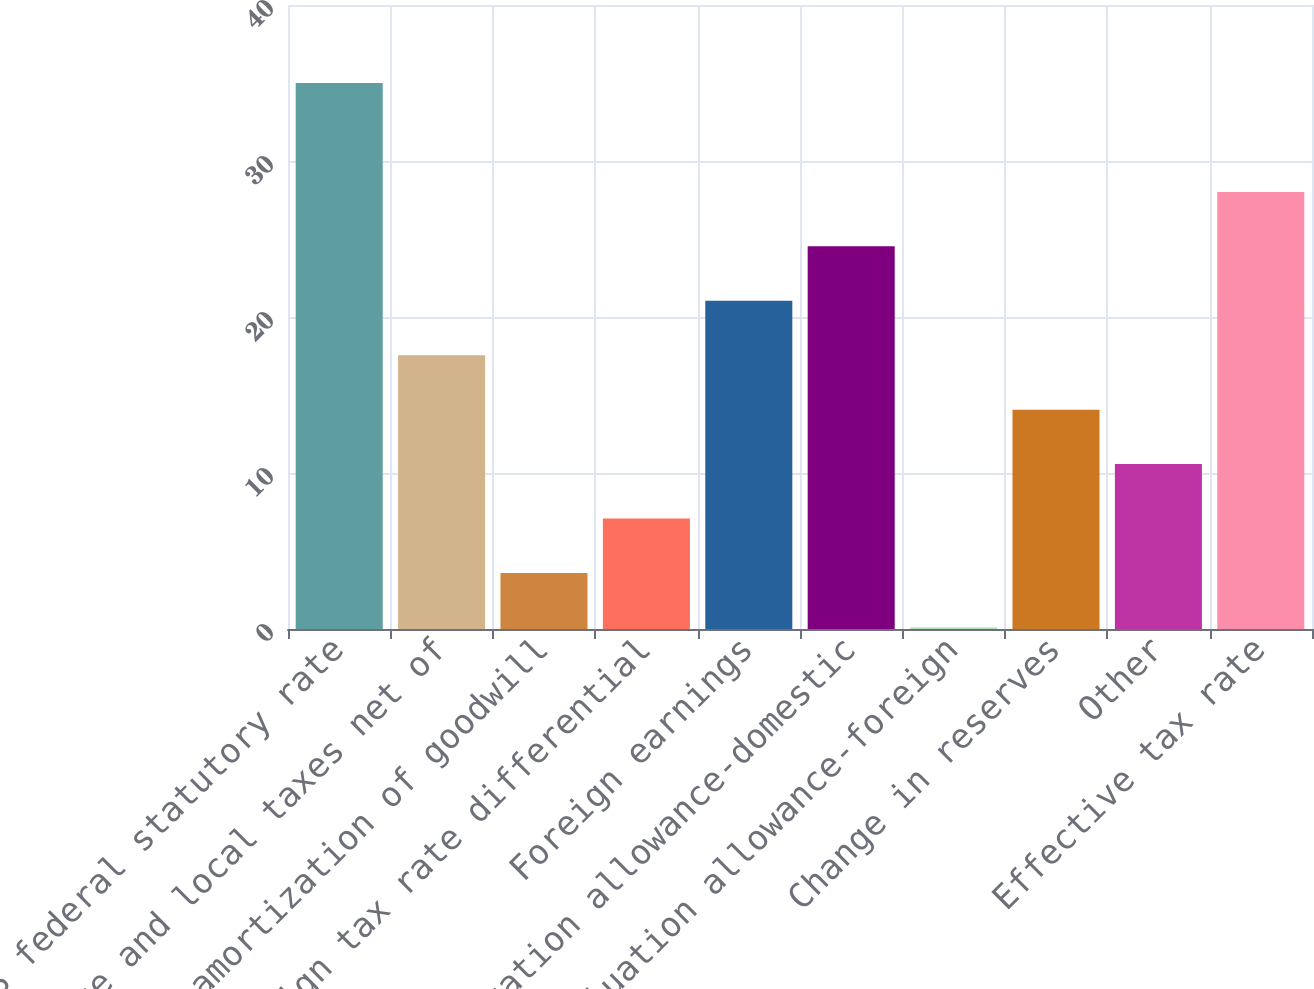Convert chart. <chart><loc_0><loc_0><loc_500><loc_500><bar_chart><fcel>US federal statutory rate<fcel>State and local taxes net of<fcel>Tax amortization of goodwill<fcel>Foreign tax rate differential<fcel>Foreign earnings<fcel>Valuation allowance-domestic<fcel>Valuation allowance-foreign<fcel>Change in reserves<fcel>Other<fcel>Effective tax rate<nl><fcel>35<fcel>17.55<fcel>3.59<fcel>7.08<fcel>21.04<fcel>24.53<fcel>0.1<fcel>14.06<fcel>10.57<fcel>28.02<nl></chart> 